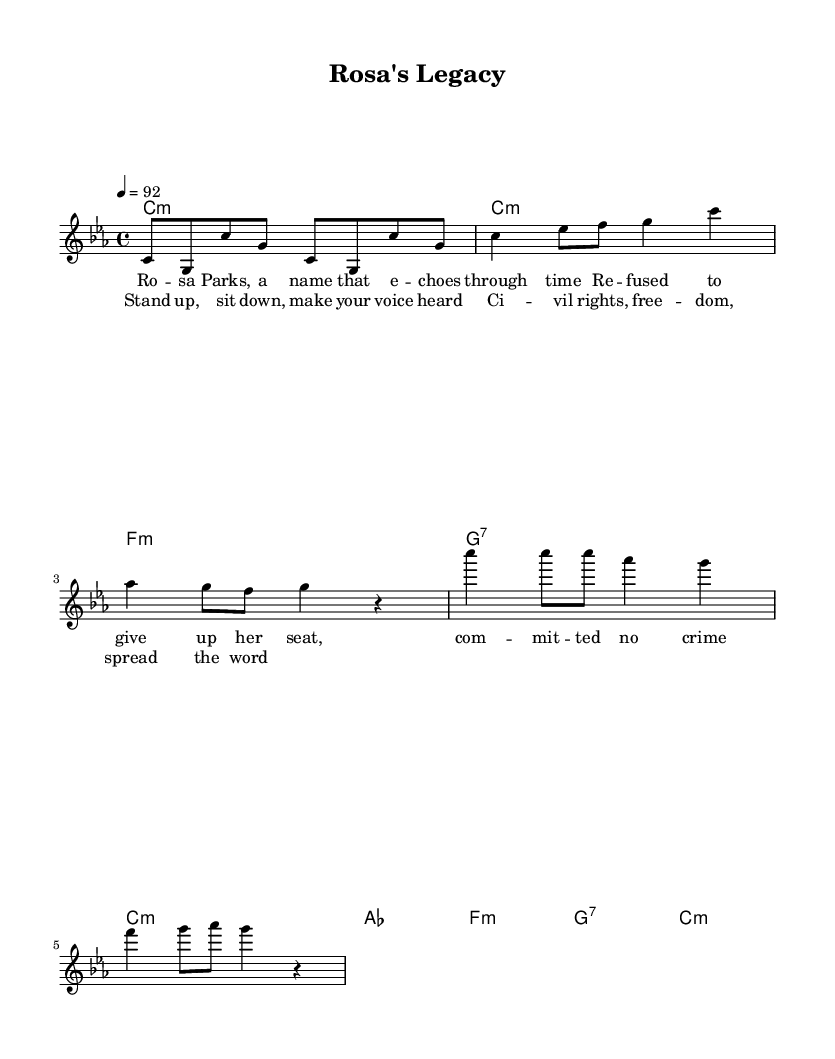What is the key signature of this music? The key signature is C minor, which has three flats: B flat, E flat, and A flat. This can be identified at the beginning of the staff, where the flats are indicated.
Answer: C minor What is the time signature of this music? The time signature is indicated at the beginning of the score as 4/4, meaning there are four beats in a measure and the quarter note gets one beat.
Answer: 4/4 What is the tempo marking for this music? The tempo marking is indicated as "4 = 92", which specifies that there are 92 beats per minute. This can be found in the tempo section of the score.
Answer: 92 How many measures are in the verse section? Counting the measures in the verse section, there are four measures present. This can be seen by the arrangement of the melody and harmonies in the associated verse lyrics.
Answer: 4 What is the name of the song represented in the sheet music? The title of the song is "Rosa's Legacy," which is indicated at the top of the score under the header section.
Answer: Rosa's Legacy What is the main theme conveyed in the chorus lyrics? The main theme of the chorus emphasizes taking action for civil rights and freedom, which aligns with the overall context of the song and its subject matter. It is derived from the content of the lyrics included with the music.
Answer: Civil rights 